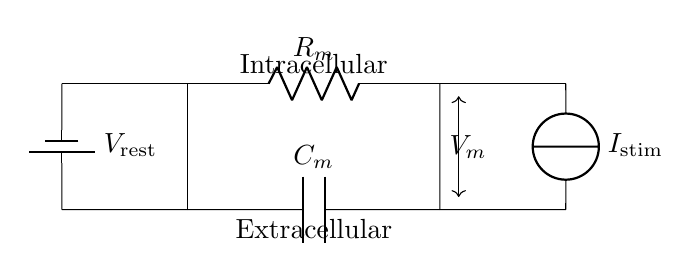What is the value of the resistor in this circuit? The circuit diagram shows a resistor labeled as R_m. The specific value is not provided in the diagram, so it cannot be determined just from the visual.
Answer: R_m What is the value of the capacitor in this circuit? The circuit shows a capacitor labeled as C_m. Like the resistor, its specific value is not defined here, so it cannot be determined visually.
Answer: C_m What is the direction of the current source? The current source is pointing downward, indicating the direction of current flow from the source to the load.
Answer: Downward What does V_m represent in this circuit? V_m is labeled next to the connection point at the bottom of the resistor and capacitor, indicating it represents the membrane potential in the neuron modeled by this RC circuit.
Answer: Membrane potential How does the capacitor behave over time in this RC circuit? In an RC circuit, the capacitor charges or discharges over time. Initially, it will charge when a voltage is applied, and the rate of charge is determined by the resistance and capacitance values. After a sufficiently long time, it will reach a steady state.
Answer: Charges and discharges If the voltage V_rest is 0, what does that imply for the membrane potential? With V_rest at 0, the baseline or resting membrane potential is initialized at zero volts. This means the neuron starts at no potential difference across its membrane, potentially influencing its response to stimulation.
Answer: Zero volts What is the role of the resistor in this circuit? The resistor (R_m) controls the flow of current into the capacitor, which affects the rate at which the voltage across the capacitor (and thus the membrane potential) changes over time.
Answer: Controls current flow 